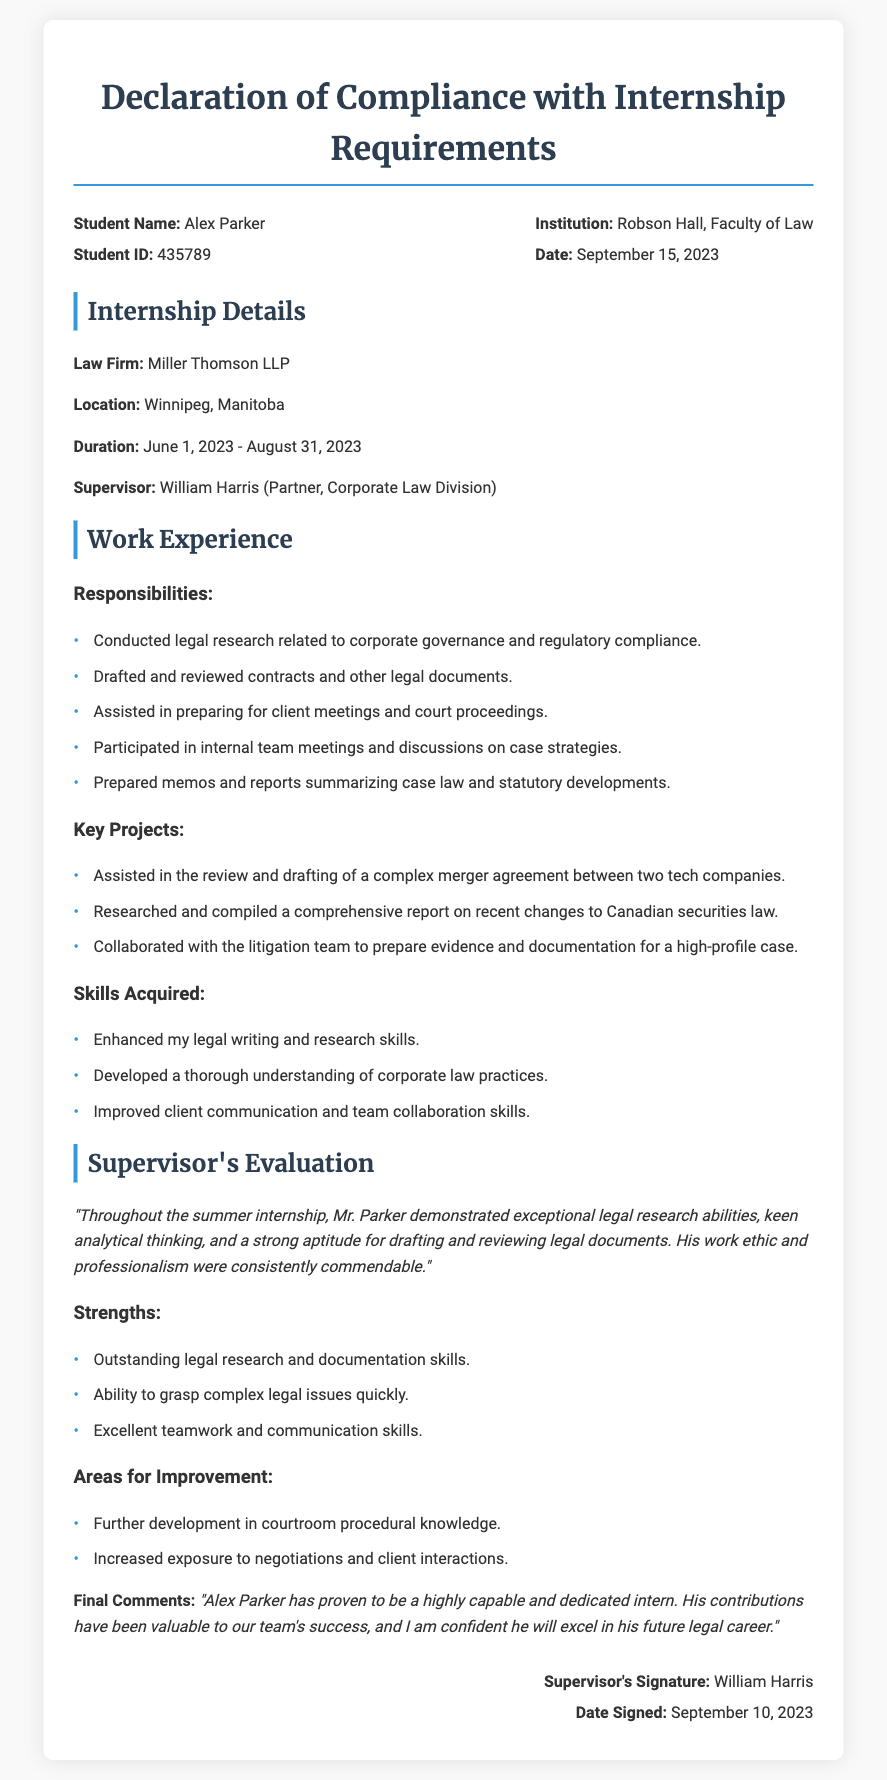What is the student's name? The document provides the name of the student as Alex Parker.
Answer: Alex Parker What is the law firm's name? The document mentions the law firm where the internship took place as Miller Thomson LLP.
Answer: Miller Thomson LLP When did the internship start? The duration of the internship beginning is clearly stated in the document as June 1, 2023.
Answer: June 1, 2023 Who was the supervisor? The document identifies the supervisor during the internship as William Harris.
Answer: William Harris What were the skills acquired during the internship? The document lists the skills acquired, including enhanced legal writing and research skills.
Answer: Enhanced legal writing and research skills What was one key project worked on? The document outlines several projects; one example is the review and drafting of a complex merger agreement.
Answer: Review and drafting of a complex merger agreement What date was the declaration signed? The date when the supervisor signed the declaration is provided as September 10, 2023.
Answer: September 10, 2023 What area of improvement did the supervisor mention? The document specifies that one area for improvement is further development in courtroom procedural knowledge.
Answer: Further development in courtroom procedural knowledge What is the student's ID? The document states the student's ID as 435789.
Answer: 435789 